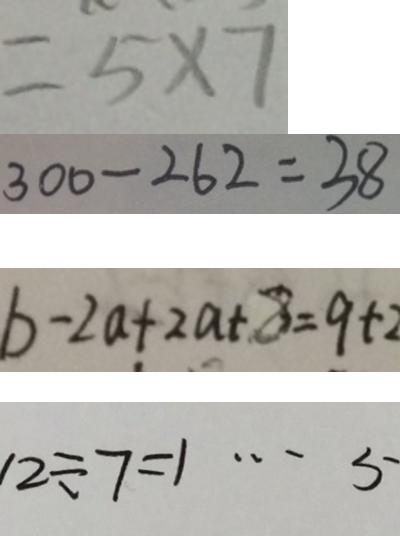Convert formula to latex. <formula><loc_0><loc_0><loc_500><loc_500>= 5 \times 7 
 3 0 0 - 2 6 2 = 3 8 
 b - 2 a + 2 a - 8 = 9 + 2 
 1 2 \div 7 = 1 \cdots 5</formula> 